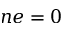Convert formula to latex. <formula><loc_0><loc_0><loc_500><loc_500>n e = 0</formula> 